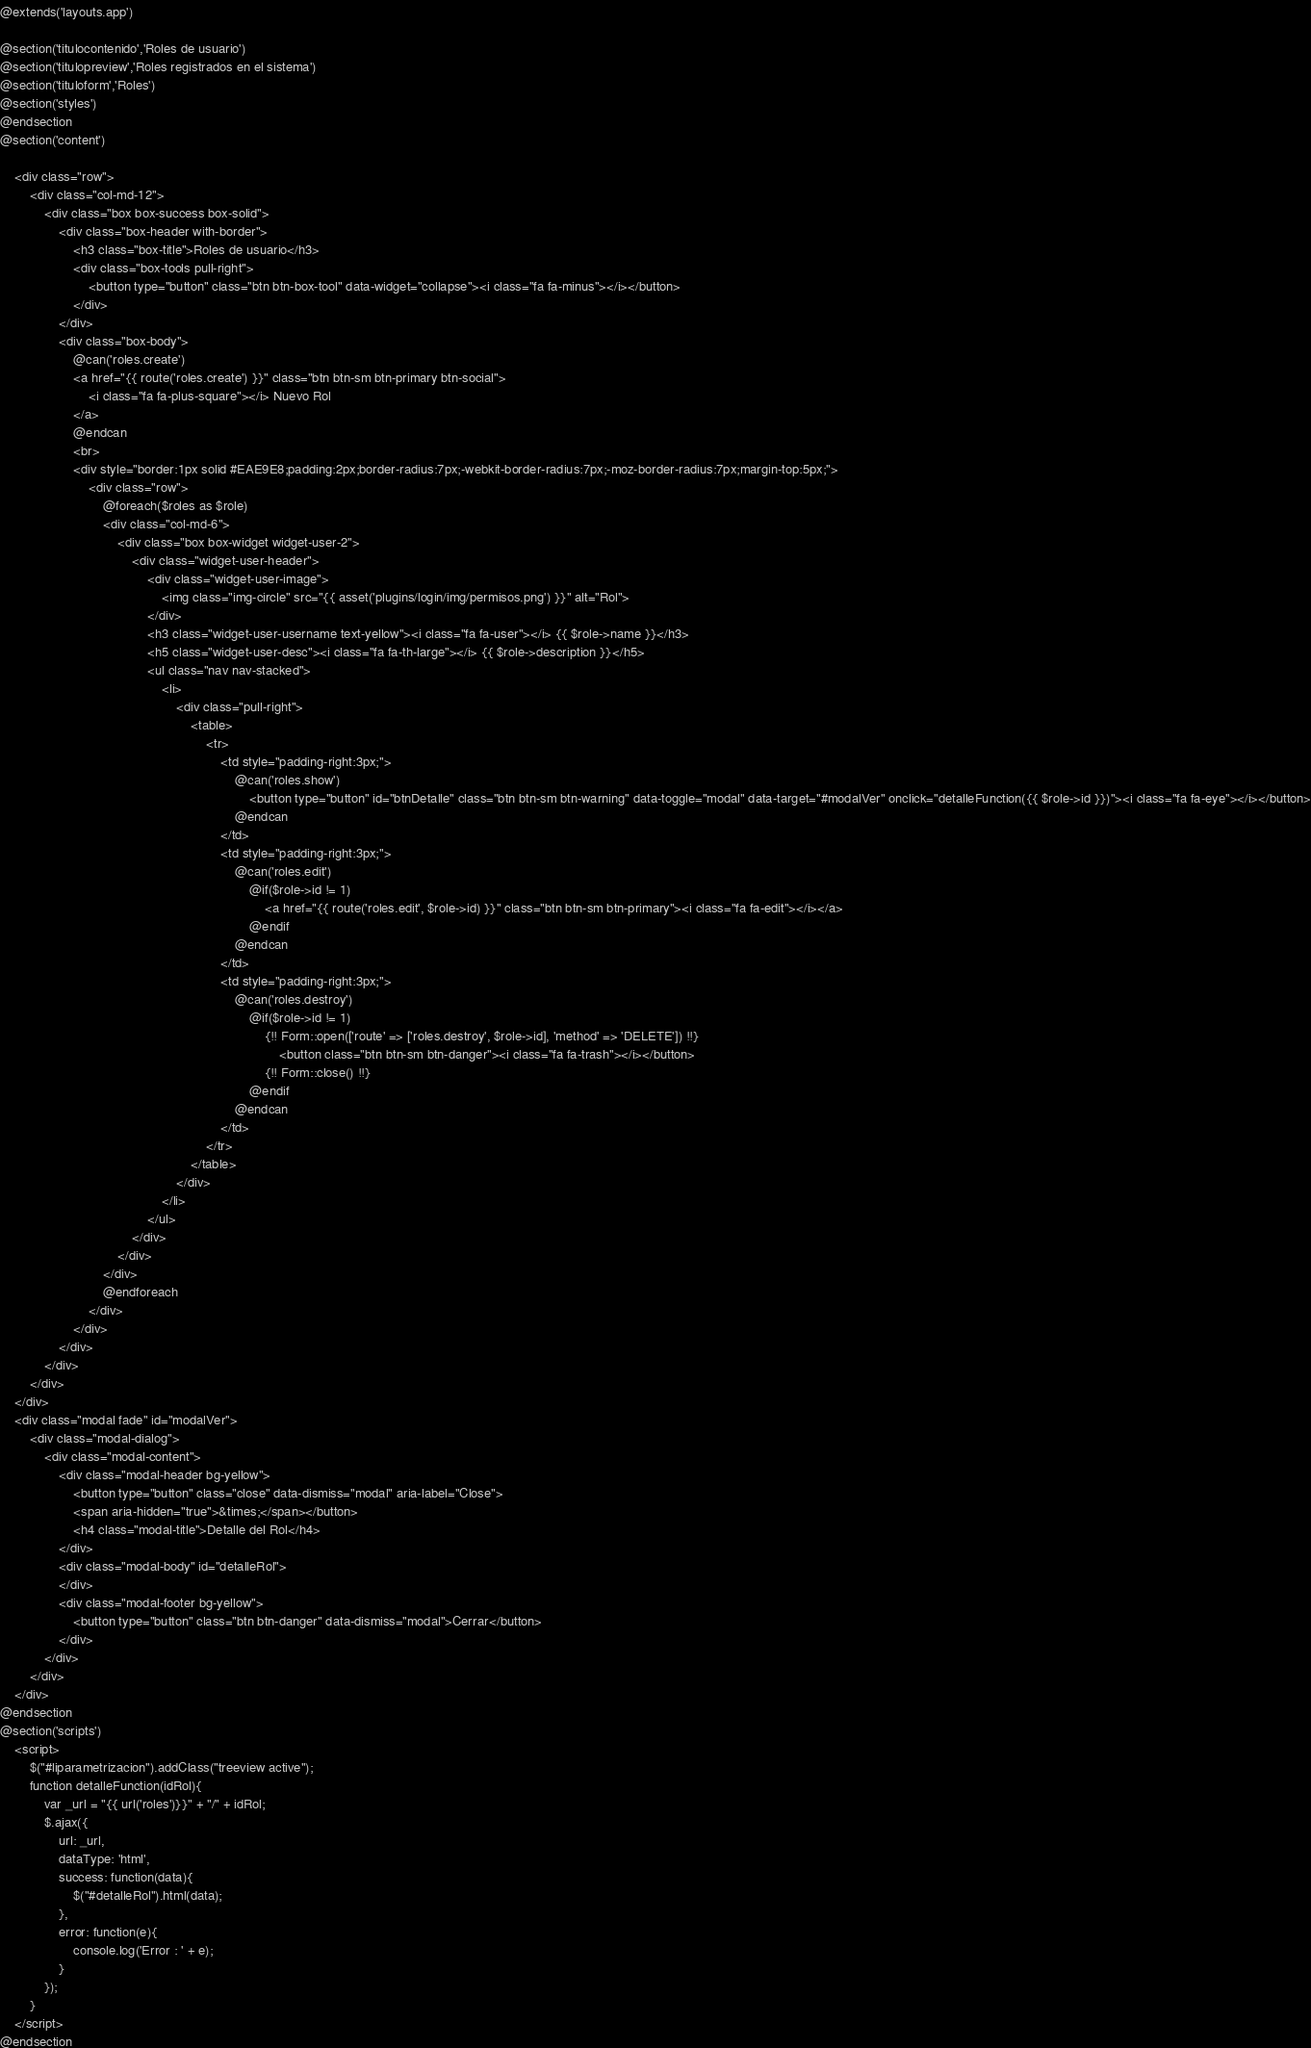Convert code to text. <code><loc_0><loc_0><loc_500><loc_500><_PHP_>@extends('layouts.app')

@section('titulocontenido','Roles de usuario')
@section('titulopreview','Roles registrados en el sistema')
@section('tituloform','Roles')
@section('styles')
@endsection
@section('content')

    <div class="row">
        <div class="col-md-12">
            <div class="box box-success box-solid">
                <div class="box-header with-border">
                    <h3 class="box-title">Roles de usuario</h3>
                    <div class="box-tools pull-right">
                        <button type="button" class="btn btn-box-tool" data-widget="collapse"><i class="fa fa-minus"></i></button>
                    </div>
                </div>
                <div class="box-body">
                    @can('roles.create')
                    <a href="{{ route('roles.create') }}" class="btn btn-sm btn-primary btn-social">
                        <i class="fa fa-plus-square"></i> Nuevo Rol
                    </a>
                    @endcan
                    <br>
                    <div style="border:1px solid #EAE9E8;padding:2px;border-radius:7px;-webkit-border-radius:7px;-moz-border-radius:7px;margin-top:5px;">
                        <div class="row">
                            @foreach($roles as $role)
                            <div class="col-md-6">
                                <div class="box box-widget widget-user-2">
                                    <div class="widget-user-header">
                                        <div class="widget-user-image">
                                            <img class="img-circle" src="{{ asset('plugins/login/img/permisos.png') }}" alt="Rol">
                                        </div>
                                        <h3 class="widget-user-username text-yellow"><i class="fa fa-user"></i> {{ $role->name }}</h3>
                                        <h5 class="widget-user-desc"><i class="fa fa-th-large"></i> {{ $role->description }}</h5>
                                        <ul class="nav nav-stacked">
                                            <li>
                                                <div class="pull-right">
                                                    <table>
                                                        <tr>
                                                            <td style="padding-right:3px;">
                                                                @can('roles.show')
                                                                    <button type="button" id="btnDetalle" class="btn btn-sm btn-warning" data-toggle="modal" data-target="#modalVer" onclick="detalleFunction({{ $role->id }})"><i class="fa fa-eye"></i></button>
                                                                @endcan
                                                            </td>
                                                            <td style="padding-right:3px;">
                                                                @can('roles.edit')
                                                                    @if($role->id != 1)
                                                                        <a href="{{ route('roles.edit', $role->id) }}" class="btn btn-sm btn-primary"><i class="fa fa-edit"></i></a>
                                                                    @endif
                                                                @endcan
                                                            </td>
                                                            <td style="padding-right:3px;">
                                                                @can('roles.destroy')
                                                                    @if($role->id != 1)
                                                                        {!! Form::open(['route' => ['roles.destroy', $role->id], 'method' => 'DELETE']) !!}
                                                                            <button class="btn btn-sm btn-danger"><i class="fa fa-trash"></i></button>
                                                                        {!! Form::close() !!}
                                                                    @endif
                                                                @endcan
                                                            </td>
                                                        </tr>
                                                    </table>
                                                </div>
                                            </li>
                                        </ul>
                                    </div>
                                </div>
                            </div>
                            @endforeach
                        </div>
                    </div>
                </div>
            </div>
        </div>
    </div>
    <div class="modal fade" id="modalVer">
        <div class="modal-dialog">
            <div class="modal-content">
                <div class="modal-header bg-yellow">
                    <button type="button" class="close" data-dismiss="modal" aria-label="Close">
                    <span aria-hidden="true">&times;</span></button>
                    <h4 class="modal-title">Detalle del Rol</h4>
                </div>
                <div class="modal-body" id="detalleRol">
                </div>
                <div class="modal-footer bg-yellow">
                    <button type="button" class="btn btn-danger" data-dismiss="modal">Cerrar</button>
                </div>
            </div>
        </div>
    </div>
@endsection
@section('scripts')
    <script>
        $("#liparametrizacion").addClass("treeview active");
        function detalleFunction(idRol){
            var _url = "{{ url('roles')}}" + "/" + idRol;
            $.ajax({
                url: _url,
                dataType: 'html',
                success: function(data){
                    $("#detalleRol").html(data);
                },
                error: function(e){
                    console.log('Error : ' + e);
                }
            });
        }
    </script>
@endsection</code> 